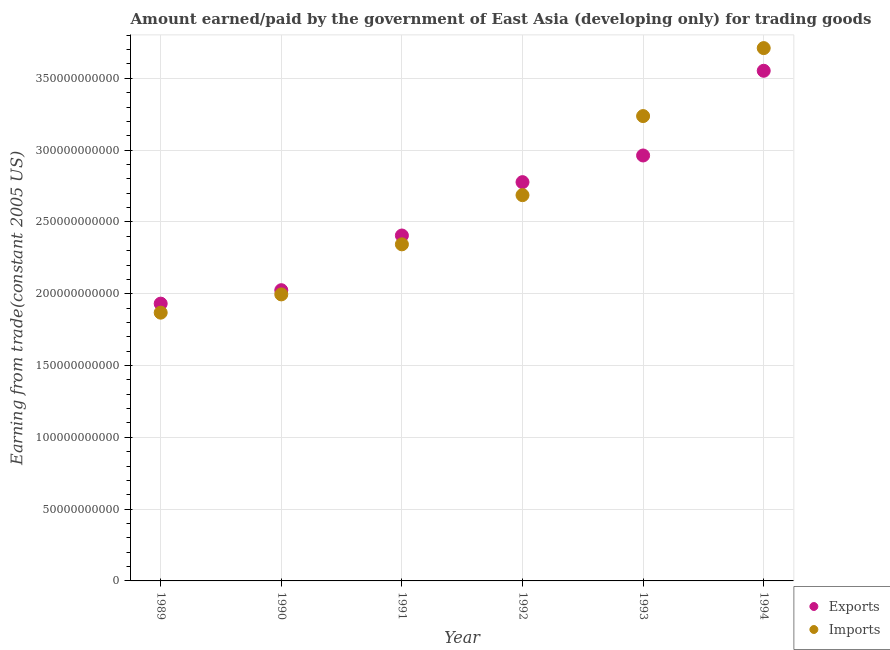How many different coloured dotlines are there?
Offer a very short reply. 2. What is the amount earned from exports in 1994?
Offer a terse response. 3.55e+11. Across all years, what is the maximum amount paid for imports?
Your answer should be compact. 3.71e+11. Across all years, what is the minimum amount paid for imports?
Your response must be concise. 1.87e+11. In which year was the amount paid for imports maximum?
Ensure brevity in your answer.  1994. What is the total amount earned from exports in the graph?
Your response must be concise. 1.57e+12. What is the difference between the amount paid for imports in 1992 and that in 1993?
Provide a succinct answer. -5.51e+1. What is the difference between the amount paid for imports in 1994 and the amount earned from exports in 1991?
Offer a very short reply. 1.31e+11. What is the average amount earned from exports per year?
Provide a succinct answer. 2.61e+11. In the year 1990, what is the difference between the amount earned from exports and amount paid for imports?
Your response must be concise. 2.93e+09. What is the ratio of the amount earned from exports in 1989 to that in 1993?
Offer a terse response. 0.65. Is the amount paid for imports in 1990 less than that in 1992?
Offer a very short reply. Yes. What is the difference between the highest and the second highest amount paid for imports?
Keep it short and to the point. 4.73e+1. What is the difference between the highest and the lowest amount paid for imports?
Your response must be concise. 1.84e+11. In how many years, is the amount earned from exports greater than the average amount earned from exports taken over all years?
Your answer should be compact. 3. Does the amount paid for imports monotonically increase over the years?
Your response must be concise. Yes. Is the amount earned from exports strictly greater than the amount paid for imports over the years?
Your answer should be very brief. No. Is the amount paid for imports strictly less than the amount earned from exports over the years?
Your answer should be compact. No. How many dotlines are there?
Make the answer very short. 2. Does the graph contain any zero values?
Your answer should be compact. No. What is the title of the graph?
Your answer should be compact. Amount earned/paid by the government of East Asia (developing only) for trading goods. What is the label or title of the X-axis?
Your answer should be very brief. Year. What is the label or title of the Y-axis?
Ensure brevity in your answer.  Earning from trade(constant 2005 US). What is the Earning from trade(constant 2005 US) in Exports in 1989?
Your answer should be very brief. 1.93e+11. What is the Earning from trade(constant 2005 US) in Imports in 1989?
Offer a very short reply. 1.87e+11. What is the Earning from trade(constant 2005 US) of Exports in 1990?
Keep it short and to the point. 2.02e+11. What is the Earning from trade(constant 2005 US) of Imports in 1990?
Your answer should be compact. 2.00e+11. What is the Earning from trade(constant 2005 US) in Exports in 1991?
Keep it short and to the point. 2.41e+11. What is the Earning from trade(constant 2005 US) of Imports in 1991?
Make the answer very short. 2.34e+11. What is the Earning from trade(constant 2005 US) in Exports in 1992?
Offer a very short reply. 2.78e+11. What is the Earning from trade(constant 2005 US) of Imports in 1992?
Your answer should be compact. 2.69e+11. What is the Earning from trade(constant 2005 US) in Exports in 1993?
Give a very brief answer. 2.96e+11. What is the Earning from trade(constant 2005 US) of Imports in 1993?
Keep it short and to the point. 3.24e+11. What is the Earning from trade(constant 2005 US) of Exports in 1994?
Your answer should be compact. 3.55e+11. What is the Earning from trade(constant 2005 US) of Imports in 1994?
Give a very brief answer. 3.71e+11. Across all years, what is the maximum Earning from trade(constant 2005 US) of Exports?
Keep it short and to the point. 3.55e+11. Across all years, what is the maximum Earning from trade(constant 2005 US) of Imports?
Ensure brevity in your answer.  3.71e+11. Across all years, what is the minimum Earning from trade(constant 2005 US) in Exports?
Your answer should be very brief. 1.93e+11. Across all years, what is the minimum Earning from trade(constant 2005 US) of Imports?
Provide a short and direct response. 1.87e+11. What is the total Earning from trade(constant 2005 US) in Exports in the graph?
Provide a succinct answer. 1.57e+12. What is the total Earning from trade(constant 2005 US) in Imports in the graph?
Provide a short and direct response. 1.58e+12. What is the difference between the Earning from trade(constant 2005 US) in Exports in 1989 and that in 1990?
Keep it short and to the point. -9.35e+09. What is the difference between the Earning from trade(constant 2005 US) in Imports in 1989 and that in 1990?
Offer a very short reply. -1.27e+1. What is the difference between the Earning from trade(constant 2005 US) of Exports in 1989 and that in 1991?
Provide a short and direct response. -4.74e+1. What is the difference between the Earning from trade(constant 2005 US) of Imports in 1989 and that in 1991?
Offer a very short reply. -4.76e+1. What is the difference between the Earning from trade(constant 2005 US) of Exports in 1989 and that in 1992?
Your response must be concise. -8.46e+1. What is the difference between the Earning from trade(constant 2005 US) in Imports in 1989 and that in 1992?
Make the answer very short. -8.18e+1. What is the difference between the Earning from trade(constant 2005 US) of Exports in 1989 and that in 1993?
Offer a very short reply. -1.03e+11. What is the difference between the Earning from trade(constant 2005 US) of Imports in 1989 and that in 1993?
Your answer should be very brief. -1.37e+11. What is the difference between the Earning from trade(constant 2005 US) in Exports in 1989 and that in 1994?
Your answer should be very brief. -1.62e+11. What is the difference between the Earning from trade(constant 2005 US) in Imports in 1989 and that in 1994?
Provide a short and direct response. -1.84e+11. What is the difference between the Earning from trade(constant 2005 US) in Exports in 1990 and that in 1991?
Give a very brief answer. -3.81e+1. What is the difference between the Earning from trade(constant 2005 US) of Imports in 1990 and that in 1991?
Your response must be concise. -3.49e+1. What is the difference between the Earning from trade(constant 2005 US) of Exports in 1990 and that in 1992?
Keep it short and to the point. -7.53e+1. What is the difference between the Earning from trade(constant 2005 US) in Imports in 1990 and that in 1992?
Ensure brevity in your answer.  -6.91e+1. What is the difference between the Earning from trade(constant 2005 US) of Exports in 1990 and that in 1993?
Your answer should be compact. -9.38e+1. What is the difference between the Earning from trade(constant 2005 US) in Imports in 1990 and that in 1993?
Make the answer very short. -1.24e+11. What is the difference between the Earning from trade(constant 2005 US) in Exports in 1990 and that in 1994?
Keep it short and to the point. -1.53e+11. What is the difference between the Earning from trade(constant 2005 US) in Imports in 1990 and that in 1994?
Offer a very short reply. -1.72e+11. What is the difference between the Earning from trade(constant 2005 US) in Exports in 1991 and that in 1992?
Your answer should be very brief. -3.72e+1. What is the difference between the Earning from trade(constant 2005 US) in Imports in 1991 and that in 1992?
Provide a succinct answer. -3.43e+1. What is the difference between the Earning from trade(constant 2005 US) of Exports in 1991 and that in 1993?
Your response must be concise. -5.57e+1. What is the difference between the Earning from trade(constant 2005 US) of Imports in 1991 and that in 1993?
Provide a succinct answer. -8.93e+1. What is the difference between the Earning from trade(constant 2005 US) in Exports in 1991 and that in 1994?
Provide a succinct answer. -1.15e+11. What is the difference between the Earning from trade(constant 2005 US) of Imports in 1991 and that in 1994?
Your answer should be compact. -1.37e+11. What is the difference between the Earning from trade(constant 2005 US) in Exports in 1992 and that in 1993?
Keep it short and to the point. -1.86e+1. What is the difference between the Earning from trade(constant 2005 US) in Imports in 1992 and that in 1993?
Ensure brevity in your answer.  -5.51e+1. What is the difference between the Earning from trade(constant 2005 US) in Exports in 1992 and that in 1994?
Give a very brief answer. -7.76e+1. What is the difference between the Earning from trade(constant 2005 US) of Imports in 1992 and that in 1994?
Offer a very short reply. -1.02e+11. What is the difference between the Earning from trade(constant 2005 US) in Exports in 1993 and that in 1994?
Offer a terse response. -5.90e+1. What is the difference between the Earning from trade(constant 2005 US) in Imports in 1993 and that in 1994?
Provide a succinct answer. -4.73e+1. What is the difference between the Earning from trade(constant 2005 US) in Exports in 1989 and the Earning from trade(constant 2005 US) in Imports in 1990?
Offer a terse response. -6.43e+09. What is the difference between the Earning from trade(constant 2005 US) of Exports in 1989 and the Earning from trade(constant 2005 US) of Imports in 1991?
Your answer should be very brief. -4.13e+1. What is the difference between the Earning from trade(constant 2005 US) of Exports in 1989 and the Earning from trade(constant 2005 US) of Imports in 1992?
Make the answer very short. -7.56e+1. What is the difference between the Earning from trade(constant 2005 US) of Exports in 1989 and the Earning from trade(constant 2005 US) of Imports in 1993?
Your answer should be very brief. -1.31e+11. What is the difference between the Earning from trade(constant 2005 US) of Exports in 1989 and the Earning from trade(constant 2005 US) of Imports in 1994?
Offer a terse response. -1.78e+11. What is the difference between the Earning from trade(constant 2005 US) in Exports in 1990 and the Earning from trade(constant 2005 US) in Imports in 1991?
Offer a terse response. -3.19e+1. What is the difference between the Earning from trade(constant 2005 US) of Exports in 1990 and the Earning from trade(constant 2005 US) of Imports in 1992?
Provide a short and direct response. -6.62e+1. What is the difference between the Earning from trade(constant 2005 US) of Exports in 1990 and the Earning from trade(constant 2005 US) of Imports in 1993?
Offer a very short reply. -1.21e+11. What is the difference between the Earning from trade(constant 2005 US) of Exports in 1990 and the Earning from trade(constant 2005 US) of Imports in 1994?
Give a very brief answer. -1.69e+11. What is the difference between the Earning from trade(constant 2005 US) in Exports in 1991 and the Earning from trade(constant 2005 US) in Imports in 1992?
Your answer should be very brief. -2.81e+1. What is the difference between the Earning from trade(constant 2005 US) of Exports in 1991 and the Earning from trade(constant 2005 US) of Imports in 1993?
Offer a very short reply. -8.32e+1. What is the difference between the Earning from trade(constant 2005 US) in Exports in 1991 and the Earning from trade(constant 2005 US) in Imports in 1994?
Make the answer very short. -1.31e+11. What is the difference between the Earning from trade(constant 2005 US) of Exports in 1992 and the Earning from trade(constant 2005 US) of Imports in 1993?
Keep it short and to the point. -4.60e+1. What is the difference between the Earning from trade(constant 2005 US) of Exports in 1992 and the Earning from trade(constant 2005 US) of Imports in 1994?
Offer a terse response. -9.33e+1. What is the difference between the Earning from trade(constant 2005 US) of Exports in 1993 and the Earning from trade(constant 2005 US) of Imports in 1994?
Make the answer very short. -7.48e+1. What is the average Earning from trade(constant 2005 US) in Exports per year?
Ensure brevity in your answer.  2.61e+11. What is the average Earning from trade(constant 2005 US) of Imports per year?
Provide a succinct answer. 2.64e+11. In the year 1989, what is the difference between the Earning from trade(constant 2005 US) in Exports and Earning from trade(constant 2005 US) in Imports?
Your response must be concise. 6.29e+09. In the year 1990, what is the difference between the Earning from trade(constant 2005 US) of Exports and Earning from trade(constant 2005 US) of Imports?
Your answer should be compact. 2.93e+09. In the year 1991, what is the difference between the Earning from trade(constant 2005 US) of Exports and Earning from trade(constant 2005 US) of Imports?
Your response must be concise. 6.16e+09. In the year 1992, what is the difference between the Earning from trade(constant 2005 US) of Exports and Earning from trade(constant 2005 US) of Imports?
Provide a succinct answer. 9.05e+09. In the year 1993, what is the difference between the Earning from trade(constant 2005 US) in Exports and Earning from trade(constant 2005 US) in Imports?
Make the answer very short. -2.74e+1. In the year 1994, what is the difference between the Earning from trade(constant 2005 US) in Exports and Earning from trade(constant 2005 US) in Imports?
Ensure brevity in your answer.  -1.58e+1. What is the ratio of the Earning from trade(constant 2005 US) in Exports in 1989 to that in 1990?
Offer a very short reply. 0.95. What is the ratio of the Earning from trade(constant 2005 US) in Imports in 1989 to that in 1990?
Provide a short and direct response. 0.94. What is the ratio of the Earning from trade(constant 2005 US) in Exports in 1989 to that in 1991?
Your answer should be compact. 0.8. What is the ratio of the Earning from trade(constant 2005 US) in Imports in 1989 to that in 1991?
Keep it short and to the point. 0.8. What is the ratio of the Earning from trade(constant 2005 US) in Exports in 1989 to that in 1992?
Offer a very short reply. 0.7. What is the ratio of the Earning from trade(constant 2005 US) of Imports in 1989 to that in 1992?
Provide a succinct answer. 0.7. What is the ratio of the Earning from trade(constant 2005 US) in Exports in 1989 to that in 1993?
Keep it short and to the point. 0.65. What is the ratio of the Earning from trade(constant 2005 US) in Imports in 1989 to that in 1993?
Your answer should be very brief. 0.58. What is the ratio of the Earning from trade(constant 2005 US) of Exports in 1989 to that in 1994?
Offer a very short reply. 0.54. What is the ratio of the Earning from trade(constant 2005 US) of Imports in 1989 to that in 1994?
Ensure brevity in your answer.  0.5. What is the ratio of the Earning from trade(constant 2005 US) of Exports in 1990 to that in 1991?
Your answer should be very brief. 0.84. What is the ratio of the Earning from trade(constant 2005 US) in Imports in 1990 to that in 1991?
Make the answer very short. 0.85. What is the ratio of the Earning from trade(constant 2005 US) of Exports in 1990 to that in 1992?
Your answer should be very brief. 0.73. What is the ratio of the Earning from trade(constant 2005 US) of Imports in 1990 to that in 1992?
Give a very brief answer. 0.74. What is the ratio of the Earning from trade(constant 2005 US) of Exports in 1990 to that in 1993?
Offer a terse response. 0.68. What is the ratio of the Earning from trade(constant 2005 US) in Imports in 1990 to that in 1993?
Your response must be concise. 0.62. What is the ratio of the Earning from trade(constant 2005 US) of Exports in 1990 to that in 1994?
Provide a short and direct response. 0.57. What is the ratio of the Earning from trade(constant 2005 US) of Imports in 1990 to that in 1994?
Your answer should be very brief. 0.54. What is the ratio of the Earning from trade(constant 2005 US) of Exports in 1991 to that in 1992?
Ensure brevity in your answer.  0.87. What is the ratio of the Earning from trade(constant 2005 US) of Imports in 1991 to that in 1992?
Offer a very short reply. 0.87. What is the ratio of the Earning from trade(constant 2005 US) of Exports in 1991 to that in 1993?
Make the answer very short. 0.81. What is the ratio of the Earning from trade(constant 2005 US) in Imports in 1991 to that in 1993?
Keep it short and to the point. 0.72. What is the ratio of the Earning from trade(constant 2005 US) in Exports in 1991 to that in 1994?
Offer a terse response. 0.68. What is the ratio of the Earning from trade(constant 2005 US) in Imports in 1991 to that in 1994?
Make the answer very short. 0.63. What is the ratio of the Earning from trade(constant 2005 US) of Exports in 1992 to that in 1993?
Give a very brief answer. 0.94. What is the ratio of the Earning from trade(constant 2005 US) of Imports in 1992 to that in 1993?
Ensure brevity in your answer.  0.83. What is the ratio of the Earning from trade(constant 2005 US) in Exports in 1992 to that in 1994?
Your answer should be compact. 0.78. What is the ratio of the Earning from trade(constant 2005 US) in Imports in 1992 to that in 1994?
Provide a short and direct response. 0.72. What is the ratio of the Earning from trade(constant 2005 US) in Exports in 1993 to that in 1994?
Your response must be concise. 0.83. What is the ratio of the Earning from trade(constant 2005 US) in Imports in 1993 to that in 1994?
Your answer should be very brief. 0.87. What is the difference between the highest and the second highest Earning from trade(constant 2005 US) of Exports?
Provide a succinct answer. 5.90e+1. What is the difference between the highest and the second highest Earning from trade(constant 2005 US) in Imports?
Give a very brief answer. 4.73e+1. What is the difference between the highest and the lowest Earning from trade(constant 2005 US) of Exports?
Ensure brevity in your answer.  1.62e+11. What is the difference between the highest and the lowest Earning from trade(constant 2005 US) in Imports?
Give a very brief answer. 1.84e+11. 